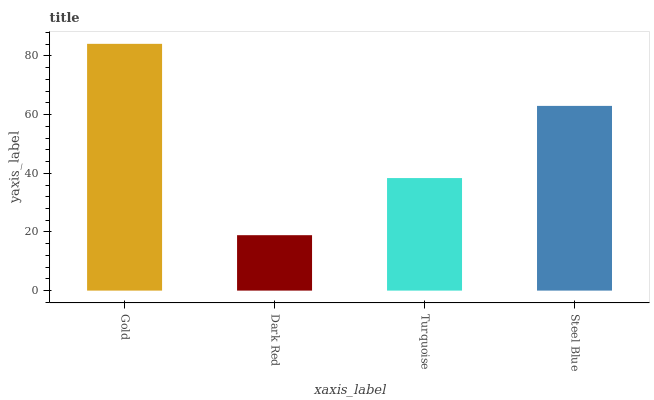Is Turquoise the minimum?
Answer yes or no. No. Is Turquoise the maximum?
Answer yes or no. No. Is Turquoise greater than Dark Red?
Answer yes or no. Yes. Is Dark Red less than Turquoise?
Answer yes or no. Yes. Is Dark Red greater than Turquoise?
Answer yes or no. No. Is Turquoise less than Dark Red?
Answer yes or no. No. Is Steel Blue the high median?
Answer yes or no. Yes. Is Turquoise the low median?
Answer yes or no. Yes. Is Gold the high median?
Answer yes or no. No. Is Steel Blue the low median?
Answer yes or no. No. 